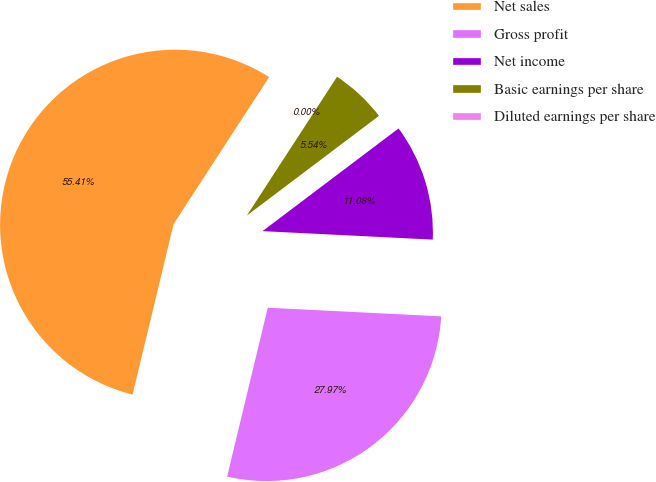Convert chart to OTSL. <chart><loc_0><loc_0><loc_500><loc_500><pie_chart><fcel>Net sales<fcel>Gross profit<fcel>Net income<fcel>Basic earnings per share<fcel>Diluted earnings per share<nl><fcel>55.41%<fcel>27.97%<fcel>11.08%<fcel>5.54%<fcel>0.0%<nl></chart> 